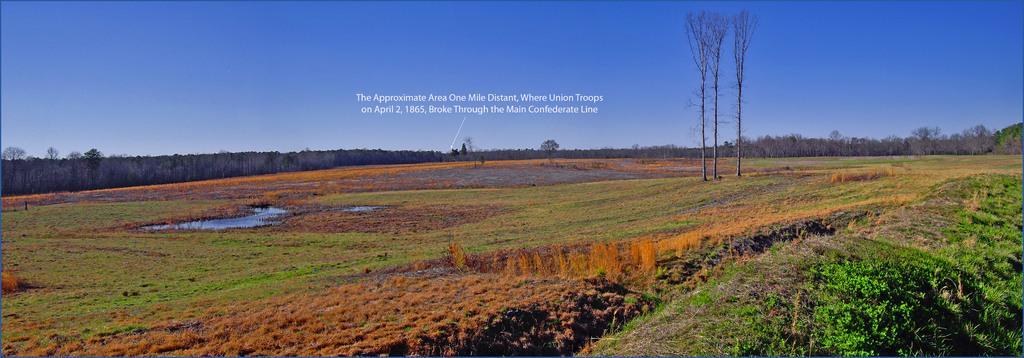Describe this image in one or two sentences. In this image I can see the grass. I can see the water. In the background, I can see the trees and the sky. 